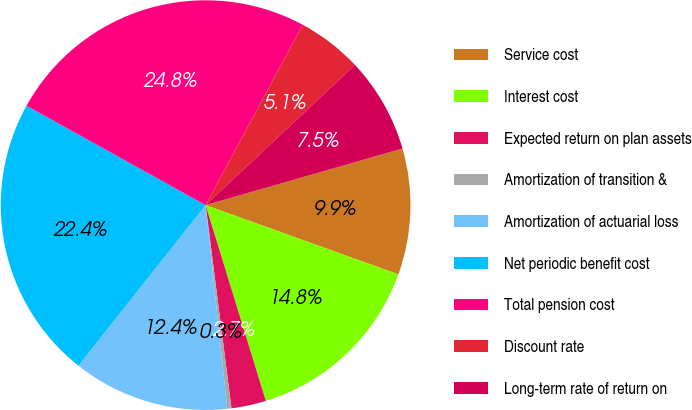Convert chart. <chart><loc_0><loc_0><loc_500><loc_500><pie_chart><fcel>Service cost<fcel>Interest cost<fcel>Expected return on plan assets<fcel>Amortization of transition &<fcel>Amortization of actuarial loss<fcel>Net periodic benefit cost<fcel>Total pension cost<fcel>Discount rate<fcel>Long-term rate of return on<nl><fcel>9.95%<fcel>14.76%<fcel>2.73%<fcel>0.33%<fcel>12.35%<fcel>22.4%<fcel>24.8%<fcel>5.14%<fcel>7.54%<nl></chart> 